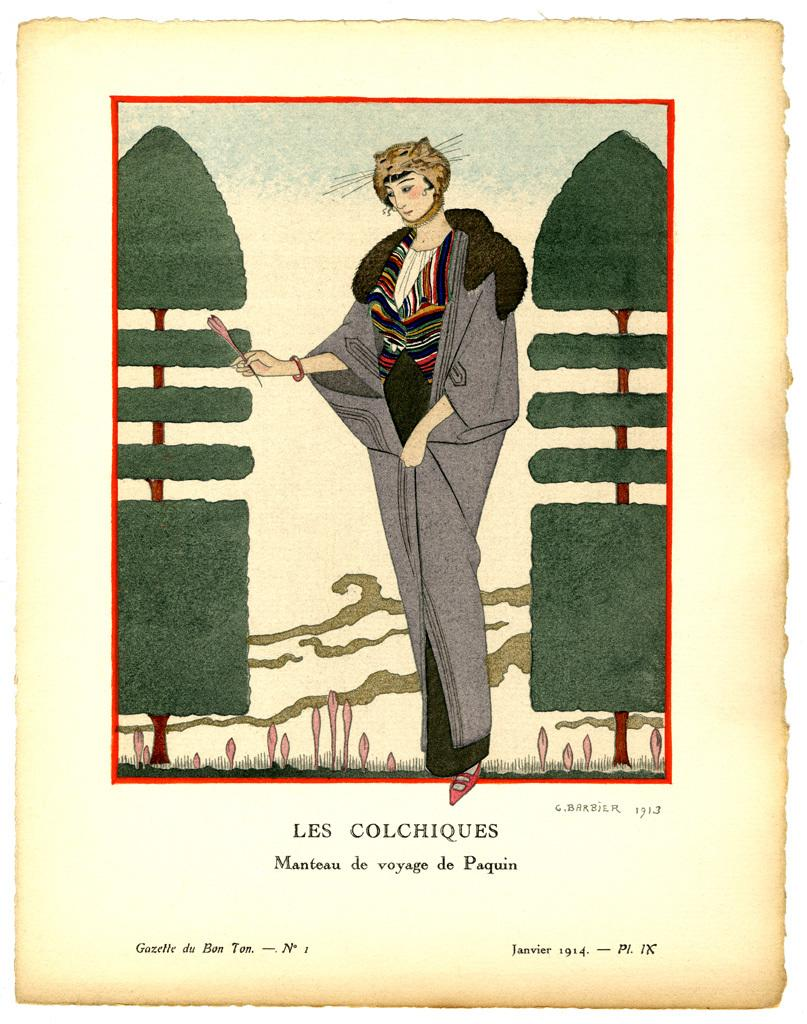What is featured on the poster in the image? The poster contains a person and trees. Can you describe the person depicted on the poster? Unfortunately, the provided facts do not give any details about the person on the poster. What type of setting is shown on the poster? The poster contains trees, which suggests a natural or outdoor setting. What color is the curtain hanging near the railway in the image? There is no curtain or railway present in the image; it only features a poster with a person and trees. 